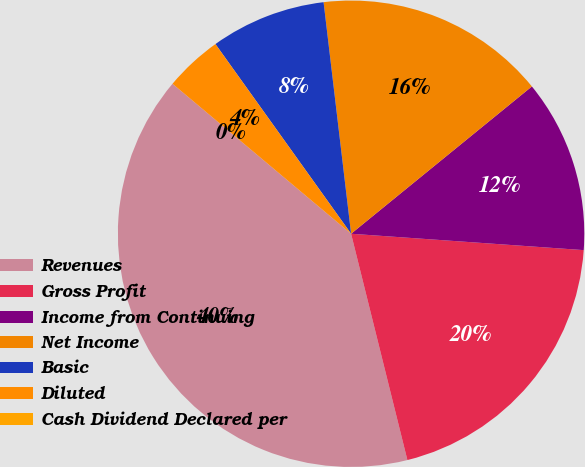Convert chart to OTSL. <chart><loc_0><loc_0><loc_500><loc_500><pie_chart><fcel>Revenues<fcel>Gross Profit<fcel>Income from Continuing<fcel>Net Income<fcel>Basic<fcel>Diluted<fcel>Cash Dividend Declared per<nl><fcel>40.0%<fcel>20.0%<fcel>12.0%<fcel>16.0%<fcel>8.0%<fcel>4.0%<fcel>0.0%<nl></chart> 